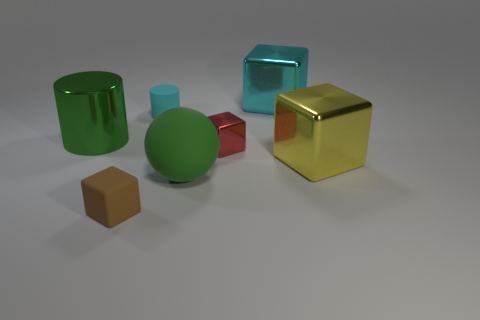There is a big shiny thing in front of the large shiny object that is left of the tiny cyan rubber cylinder; is there a cyan metal cube in front of it?
Offer a very short reply. No. Are there any green shiny cylinders on the right side of the large yellow metal block?
Ensure brevity in your answer.  No. Are there any big cubes that have the same color as the sphere?
Provide a succinct answer. No. What number of big things are cyan matte cylinders or cyan blocks?
Keep it short and to the point. 1. Is the green object right of the big shiny cylinder made of the same material as the cyan block?
Your response must be concise. No. There is a large green object in front of the tiny block behind the metallic object to the right of the cyan block; what shape is it?
Your response must be concise. Sphere. How many red objects are shiny blocks or tiny rubber cylinders?
Your response must be concise. 1. Is the number of big metallic cylinders to the left of the cyan rubber cylinder the same as the number of tiny rubber blocks that are on the right side of the matte sphere?
Give a very brief answer. No. Is the shape of the large object right of the cyan shiny thing the same as the rubber thing that is behind the matte ball?
Your answer should be compact. No. Are there any other things that are the same shape as the tiny brown matte thing?
Offer a terse response. Yes. 